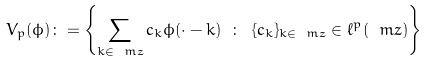<formula> <loc_0><loc_0><loc_500><loc_500>V _ { p } ( \phi ) \colon = \left \{ \sum _ { k \in \ m z } c _ { k } \phi ( \cdot - k ) \ \colon \ \{ c _ { k } \} _ { k \in \ m z } \in \ell ^ { p } ( \ m z ) \right \}</formula> 